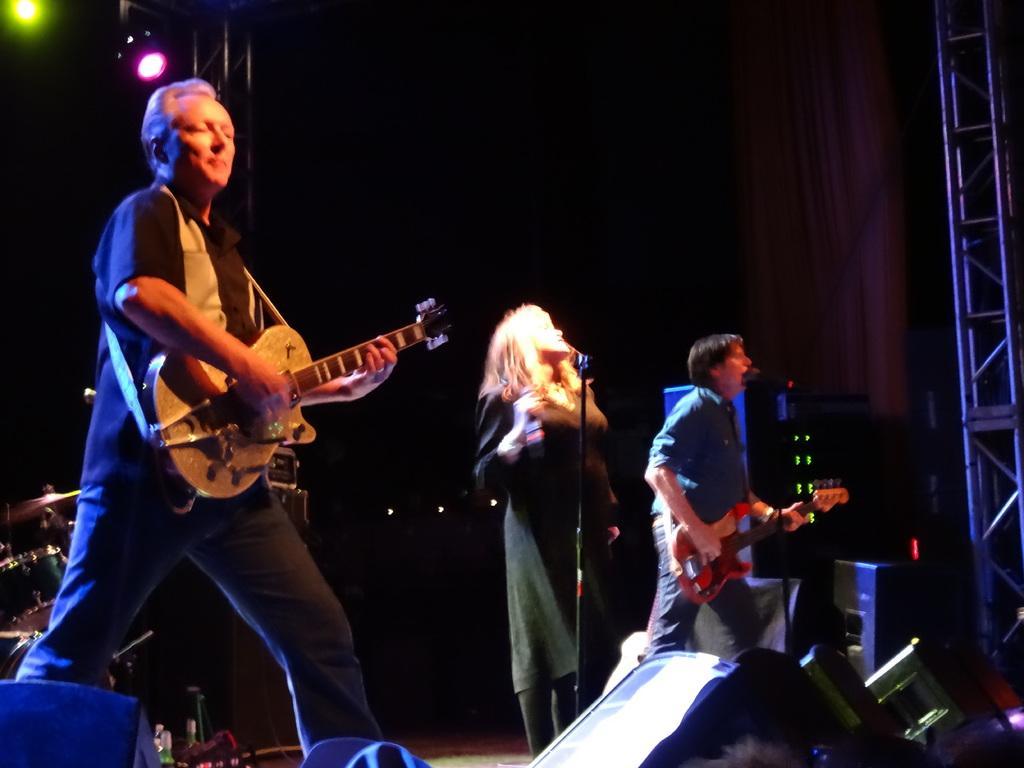Describe this image in one or two sentences. In this image I see 2 men and a woman who are standing and I can also see that these are holding the guitars. In the background I see the musical instrument and the lights. 